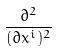Convert formula to latex. <formula><loc_0><loc_0><loc_500><loc_500>\frac { \partial ^ { 2 } } { ( \partial x ^ { i } ) ^ { 2 } }</formula> 